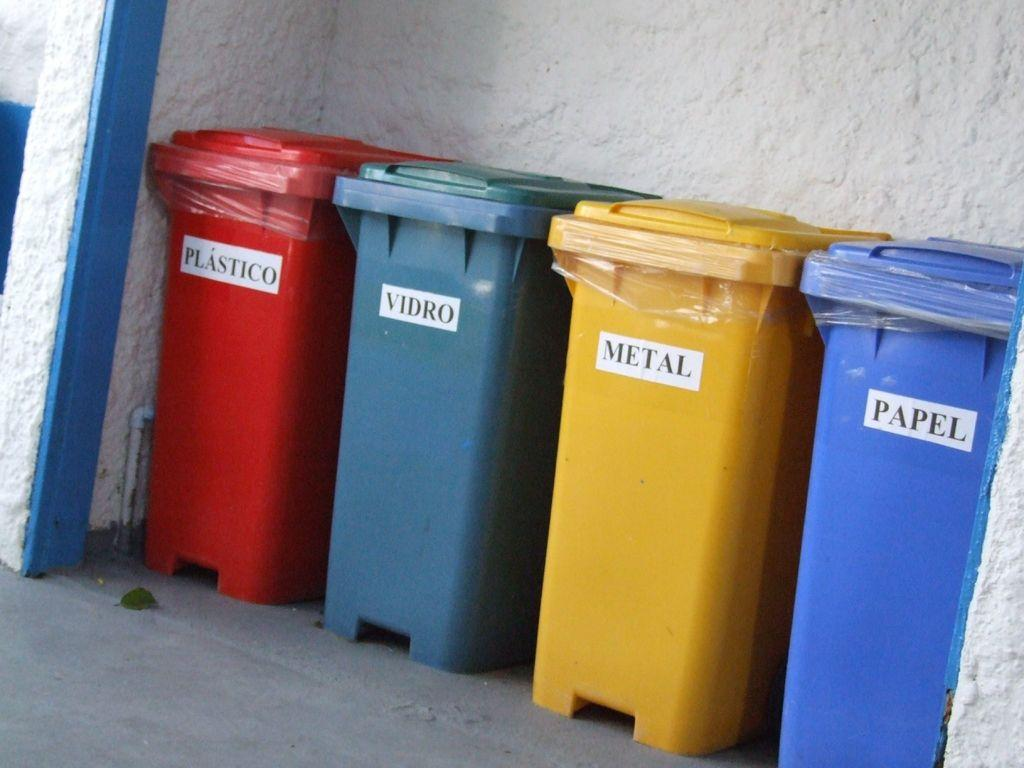<image>
Relay a brief, clear account of the picture shown. A series of bins that say Plastico, Vidro, Metal, and Papel. 